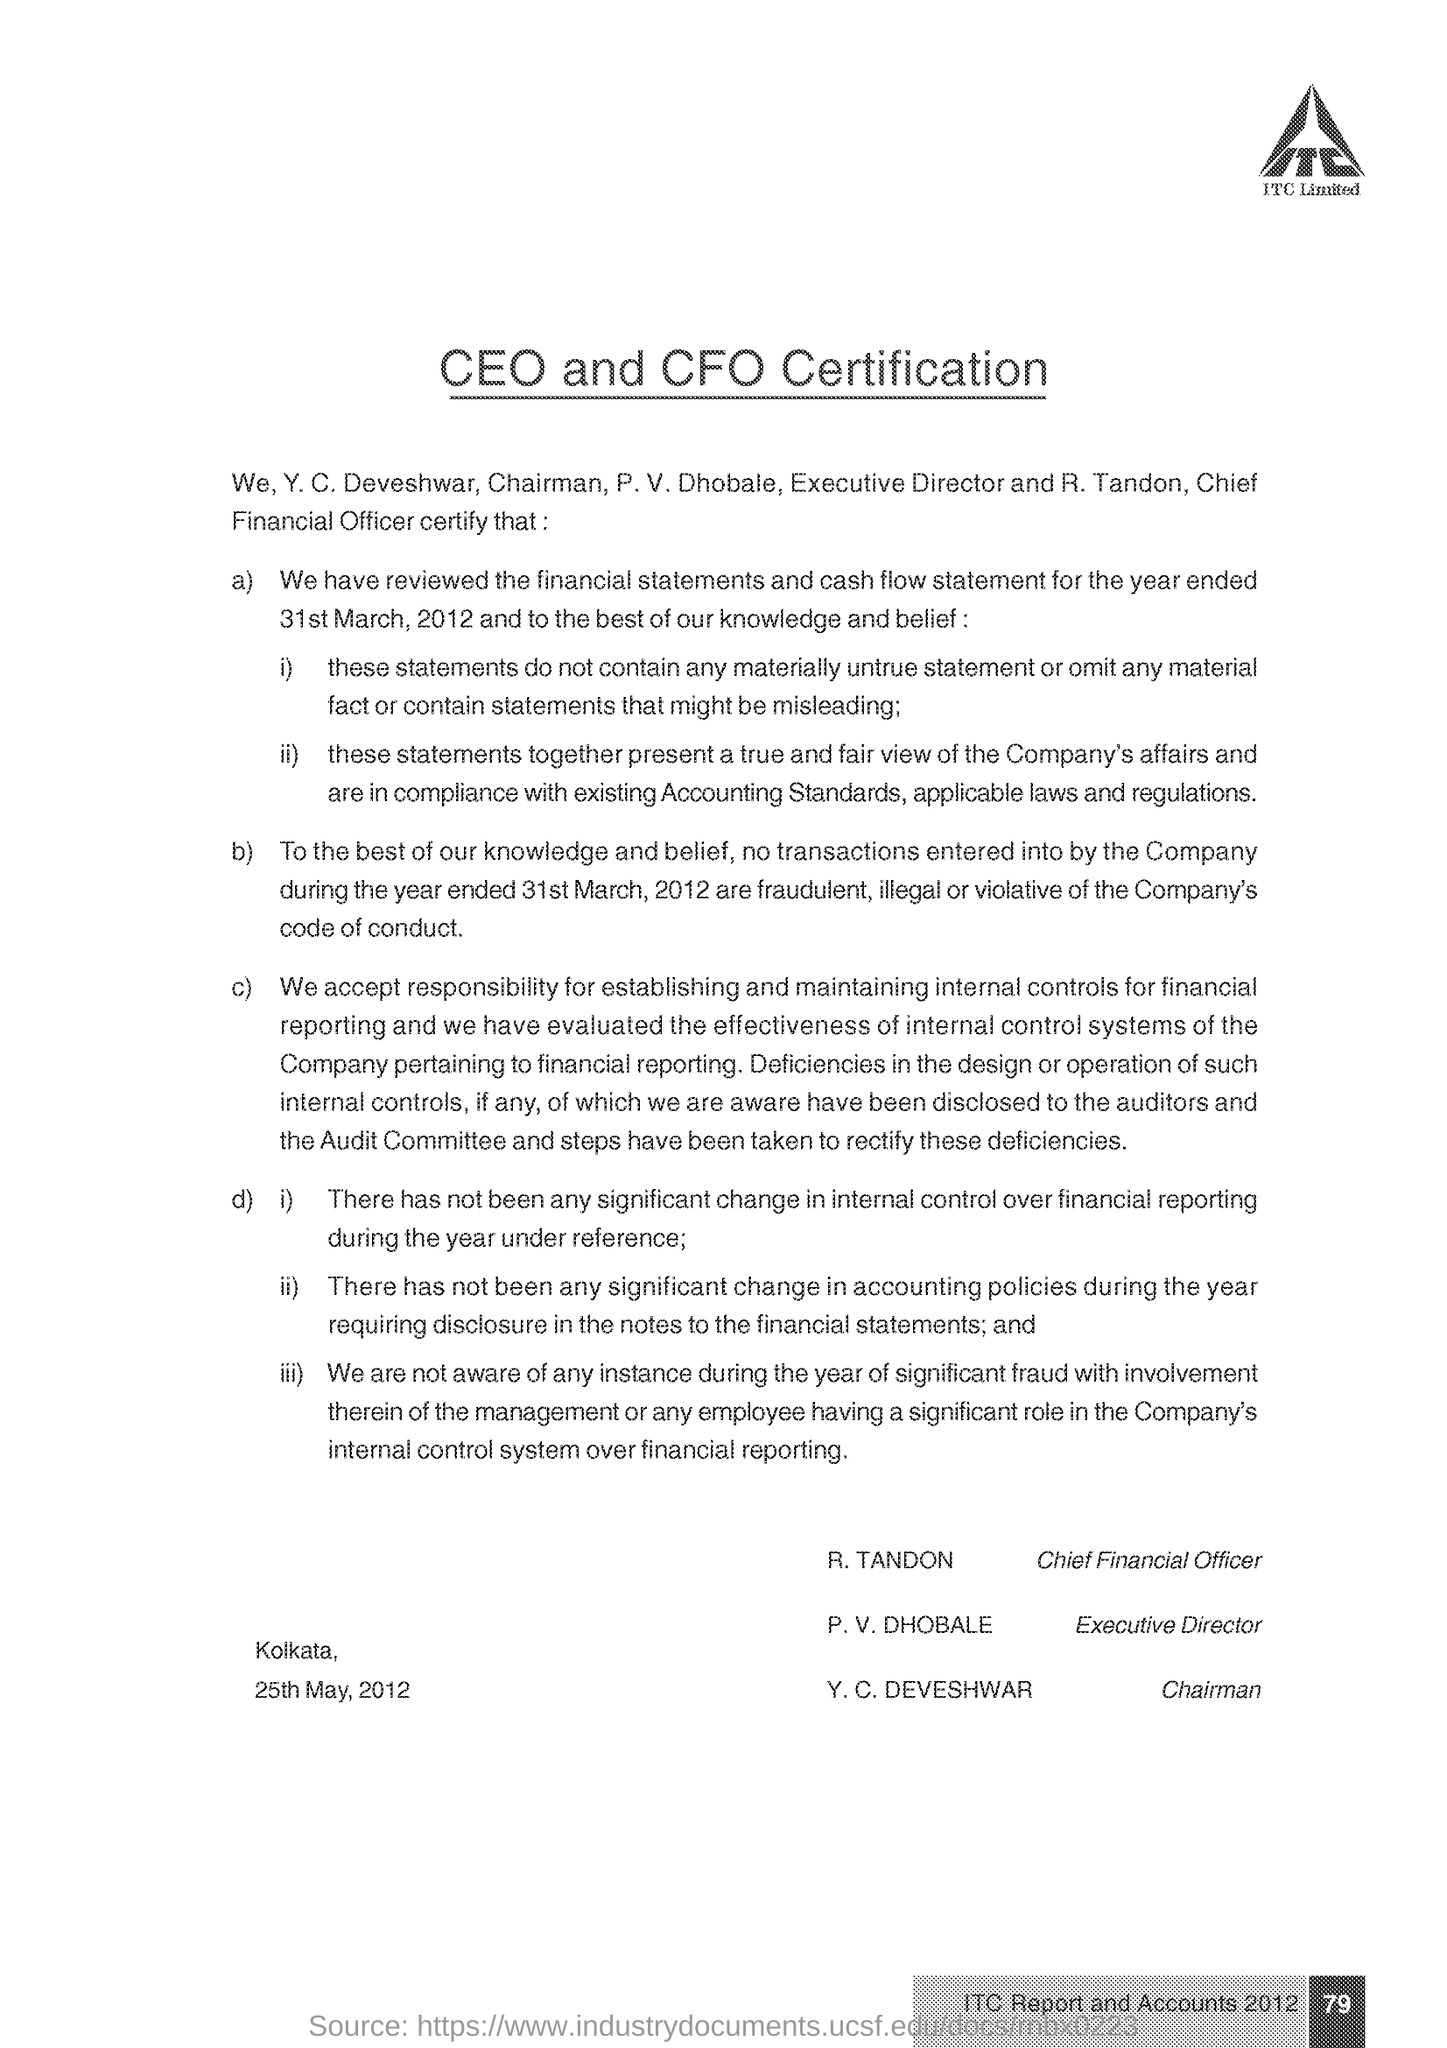Specify some key components in this picture. Y. C. Deveshwar is the Chairman of . P. V. Dhobale holds the designation of Executive Director. The page number mentioned in this document is 79. The CEO and CFO certification is given here. 